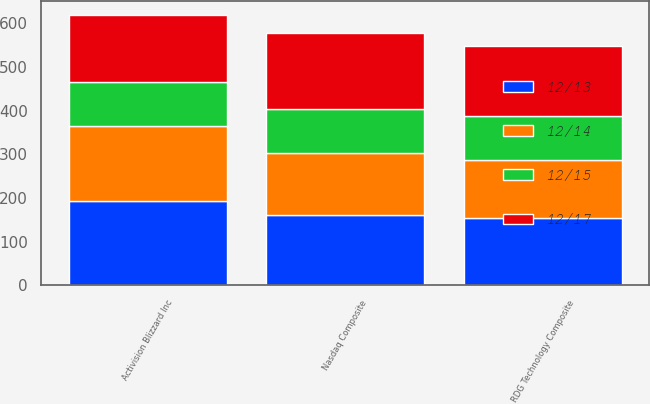<chart> <loc_0><loc_0><loc_500><loc_500><stacked_bar_chart><ecel><fcel>Activision Blizzard Inc<fcel>Nasdaq Composite<fcel>RDG Technology Composite<nl><fcel>12/15<fcel>100<fcel>100<fcel>100<nl><fcel>12/14<fcel>170.11<fcel>141.63<fcel>132.51<nl><fcel>12/13<fcel>194.06<fcel>162.09<fcel>155.05<nl><fcel>12/17<fcel>155.05<fcel>173.33<fcel>161<nl></chart> 